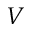<formula> <loc_0><loc_0><loc_500><loc_500>V</formula> 